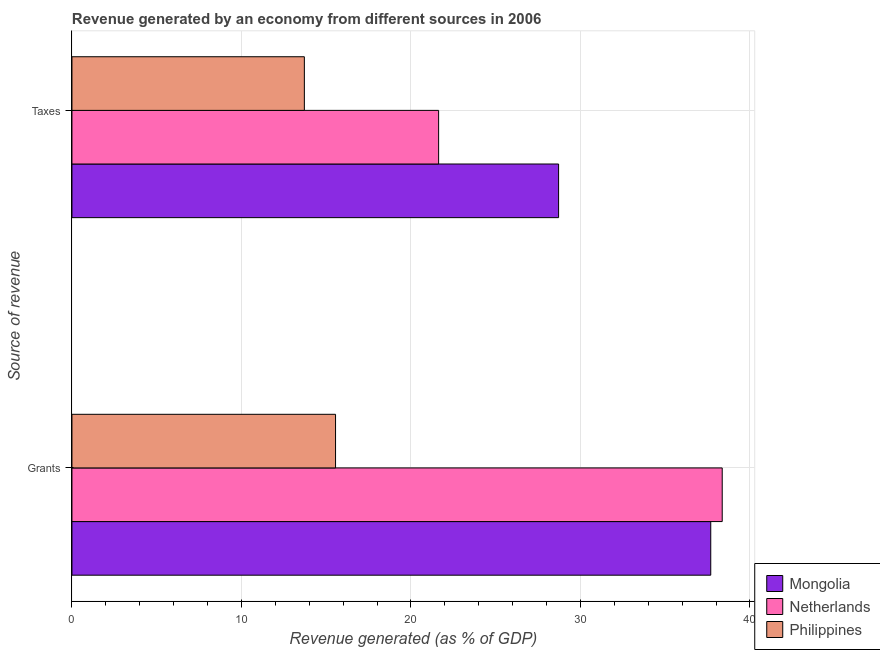How many different coloured bars are there?
Offer a terse response. 3. How many groups of bars are there?
Give a very brief answer. 2. What is the label of the 1st group of bars from the top?
Provide a short and direct response. Taxes. What is the revenue generated by taxes in Philippines?
Give a very brief answer. 13.71. Across all countries, what is the maximum revenue generated by taxes?
Provide a short and direct response. 28.71. Across all countries, what is the minimum revenue generated by grants?
Provide a succinct answer. 15.55. In which country was the revenue generated by taxes maximum?
Your answer should be very brief. Mongolia. What is the total revenue generated by taxes in the graph?
Offer a terse response. 64.05. What is the difference between the revenue generated by grants in Philippines and that in Netherlands?
Your response must be concise. -22.81. What is the difference between the revenue generated by grants in Netherlands and the revenue generated by taxes in Philippines?
Your response must be concise. 24.65. What is the average revenue generated by grants per country?
Offer a terse response. 30.53. What is the difference between the revenue generated by taxes and revenue generated by grants in Philippines?
Provide a succinct answer. -1.84. In how many countries, is the revenue generated by taxes greater than 10 %?
Your response must be concise. 3. What is the ratio of the revenue generated by grants in Netherlands to that in Mongolia?
Your answer should be compact. 1.02. Is the revenue generated by grants in Mongolia less than that in Netherlands?
Make the answer very short. Yes. In how many countries, is the revenue generated by taxes greater than the average revenue generated by taxes taken over all countries?
Your answer should be compact. 2. What does the 3rd bar from the top in Taxes represents?
Your response must be concise. Mongolia. What does the 1st bar from the bottom in Taxes represents?
Make the answer very short. Mongolia. How many bars are there?
Keep it short and to the point. 6. What is the difference between two consecutive major ticks on the X-axis?
Give a very brief answer. 10. Does the graph contain any zero values?
Your response must be concise. No. Does the graph contain grids?
Make the answer very short. Yes. How are the legend labels stacked?
Provide a succinct answer. Vertical. What is the title of the graph?
Give a very brief answer. Revenue generated by an economy from different sources in 2006. What is the label or title of the X-axis?
Your answer should be very brief. Revenue generated (as % of GDP). What is the label or title of the Y-axis?
Provide a succinct answer. Source of revenue. What is the Revenue generated (as % of GDP) in Mongolia in Grants?
Give a very brief answer. 37.69. What is the Revenue generated (as % of GDP) in Netherlands in Grants?
Ensure brevity in your answer.  38.36. What is the Revenue generated (as % of GDP) in Philippines in Grants?
Provide a short and direct response. 15.55. What is the Revenue generated (as % of GDP) of Mongolia in Taxes?
Your answer should be very brief. 28.71. What is the Revenue generated (as % of GDP) of Netherlands in Taxes?
Your answer should be very brief. 21.63. What is the Revenue generated (as % of GDP) in Philippines in Taxes?
Make the answer very short. 13.71. Across all Source of revenue, what is the maximum Revenue generated (as % of GDP) in Mongolia?
Offer a very short reply. 37.69. Across all Source of revenue, what is the maximum Revenue generated (as % of GDP) in Netherlands?
Keep it short and to the point. 38.36. Across all Source of revenue, what is the maximum Revenue generated (as % of GDP) of Philippines?
Keep it short and to the point. 15.55. Across all Source of revenue, what is the minimum Revenue generated (as % of GDP) in Mongolia?
Give a very brief answer. 28.71. Across all Source of revenue, what is the minimum Revenue generated (as % of GDP) of Netherlands?
Make the answer very short. 21.63. Across all Source of revenue, what is the minimum Revenue generated (as % of GDP) in Philippines?
Ensure brevity in your answer.  13.71. What is the total Revenue generated (as % of GDP) of Mongolia in the graph?
Keep it short and to the point. 66.4. What is the total Revenue generated (as % of GDP) in Netherlands in the graph?
Offer a terse response. 60. What is the total Revenue generated (as % of GDP) of Philippines in the graph?
Make the answer very short. 29.26. What is the difference between the Revenue generated (as % of GDP) in Mongolia in Grants and that in Taxes?
Your answer should be very brief. 8.98. What is the difference between the Revenue generated (as % of GDP) of Netherlands in Grants and that in Taxes?
Ensure brevity in your answer.  16.73. What is the difference between the Revenue generated (as % of GDP) of Philippines in Grants and that in Taxes?
Make the answer very short. 1.84. What is the difference between the Revenue generated (as % of GDP) in Mongolia in Grants and the Revenue generated (as % of GDP) in Netherlands in Taxes?
Make the answer very short. 16.05. What is the difference between the Revenue generated (as % of GDP) of Mongolia in Grants and the Revenue generated (as % of GDP) of Philippines in Taxes?
Your answer should be compact. 23.98. What is the difference between the Revenue generated (as % of GDP) of Netherlands in Grants and the Revenue generated (as % of GDP) of Philippines in Taxes?
Provide a succinct answer. 24.65. What is the average Revenue generated (as % of GDP) in Mongolia per Source of revenue?
Your response must be concise. 33.2. What is the average Revenue generated (as % of GDP) in Netherlands per Source of revenue?
Provide a short and direct response. 30. What is the average Revenue generated (as % of GDP) in Philippines per Source of revenue?
Give a very brief answer. 14.63. What is the difference between the Revenue generated (as % of GDP) in Mongolia and Revenue generated (as % of GDP) in Netherlands in Grants?
Your answer should be compact. -0.68. What is the difference between the Revenue generated (as % of GDP) in Mongolia and Revenue generated (as % of GDP) in Philippines in Grants?
Your answer should be compact. 22.14. What is the difference between the Revenue generated (as % of GDP) in Netherlands and Revenue generated (as % of GDP) in Philippines in Grants?
Offer a terse response. 22.81. What is the difference between the Revenue generated (as % of GDP) of Mongolia and Revenue generated (as % of GDP) of Netherlands in Taxes?
Your response must be concise. 7.08. What is the difference between the Revenue generated (as % of GDP) in Mongolia and Revenue generated (as % of GDP) in Philippines in Taxes?
Your response must be concise. 15. What is the difference between the Revenue generated (as % of GDP) of Netherlands and Revenue generated (as % of GDP) of Philippines in Taxes?
Provide a succinct answer. 7.92. What is the ratio of the Revenue generated (as % of GDP) of Mongolia in Grants to that in Taxes?
Give a very brief answer. 1.31. What is the ratio of the Revenue generated (as % of GDP) of Netherlands in Grants to that in Taxes?
Give a very brief answer. 1.77. What is the ratio of the Revenue generated (as % of GDP) of Philippines in Grants to that in Taxes?
Give a very brief answer. 1.13. What is the difference between the highest and the second highest Revenue generated (as % of GDP) in Mongolia?
Give a very brief answer. 8.98. What is the difference between the highest and the second highest Revenue generated (as % of GDP) of Netherlands?
Your response must be concise. 16.73. What is the difference between the highest and the second highest Revenue generated (as % of GDP) of Philippines?
Your answer should be compact. 1.84. What is the difference between the highest and the lowest Revenue generated (as % of GDP) of Mongolia?
Keep it short and to the point. 8.98. What is the difference between the highest and the lowest Revenue generated (as % of GDP) of Netherlands?
Make the answer very short. 16.73. What is the difference between the highest and the lowest Revenue generated (as % of GDP) of Philippines?
Provide a short and direct response. 1.84. 